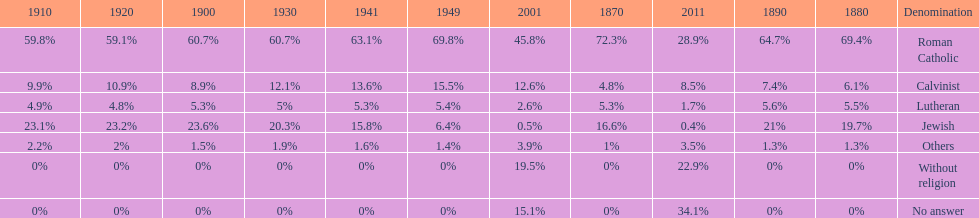Which denomination held the largest percentage in 1880? Roman Catholic. 